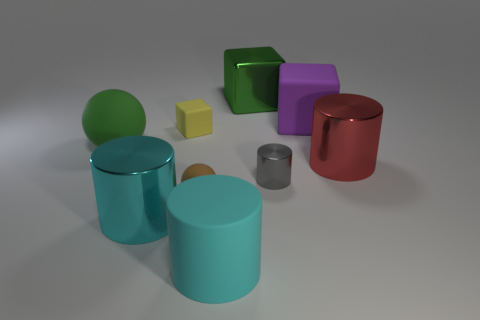How many cyan metal cylinders are on the left side of the tiny rubber thing that is behind the large red metallic thing that is in front of the large green metal thing? 1 